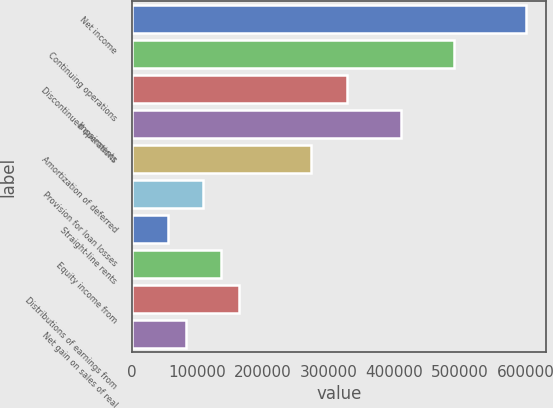Convert chart to OTSL. <chart><loc_0><loc_0><loc_500><loc_500><bar_chart><fcel>Net income<fcel>Continuing operations<fcel>Discontinued operations<fcel>Impairments<fcel>Amortization of deferred<fcel>Provision for loan losses<fcel>Straight-line rents<fcel>Equity income from<fcel>Distributions of earnings from<fcel>Net gain on sales of real<nl><fcel>600268<fcel>491130<fcel>327422<fcel>409276<fcel>272853<fcel>109145<fcel>54576.2<fcel>136430<fcel>163715<fcel>81860.8<nl></chart> 